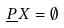<formula> <loc_0><loc_0><loc_500><loc_500>\underline { P } X = \emptyset</formula> 